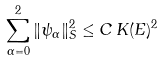Convert formula to latex. <formula><loc_0><loc_0><loc_500><loc_500>\sum _ { \alpha = 0 } ^ { 2 } \| \psi _ { \alpha } \| ^ { 2 } _ { S } \leq C \, K ( E ) ^ { 2 }</formula> 